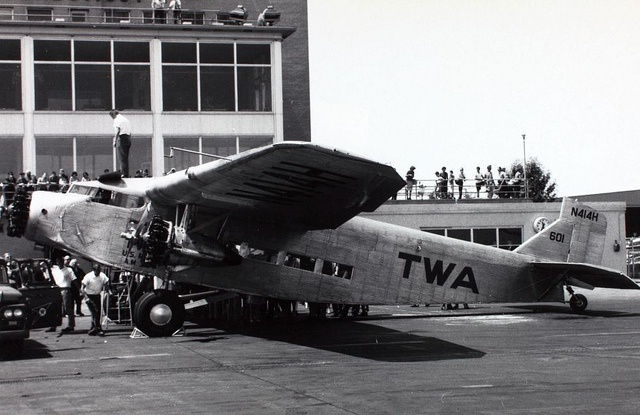Describe the objects in this image and their specific colors. I can see airplane in gray, black, darkgray, and lightgray tones, truck in gray, black, darkgray, and lightgray tones, people in gray, black, white, and darkgray tones, people in gray, black, darkgray, and lightgray tones, and people in gray, black, white, and darkgray tones in this image. 